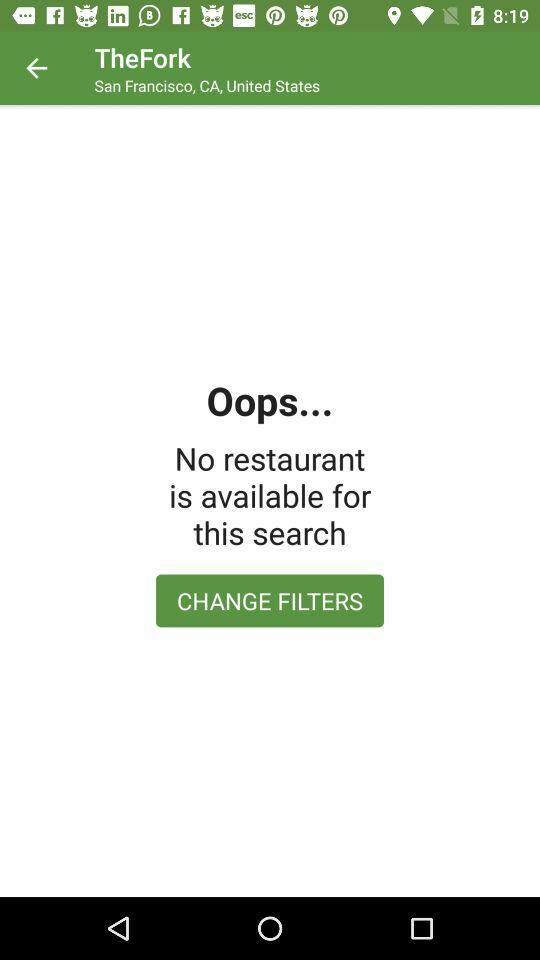What is the mentioned location? The mentioned location is San Francisco, CA, United States. 